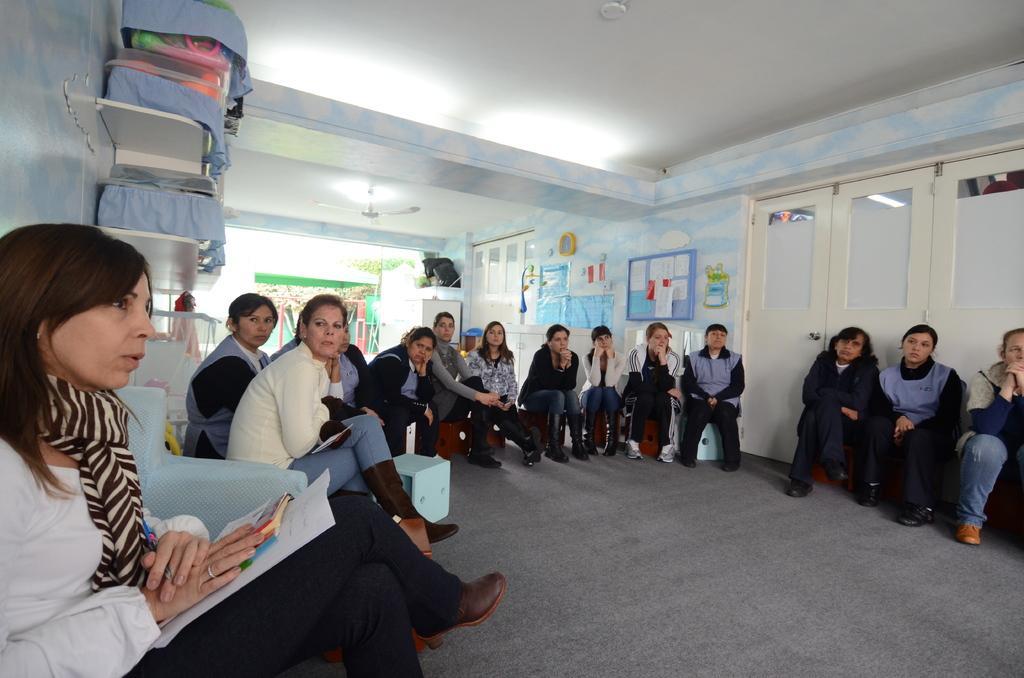Describe this image in one or two sentences. This picture describes about group of people, they are all seated, on the left side of the image we can find boxes on the shelves, in the background we can find few posters on the wall. 